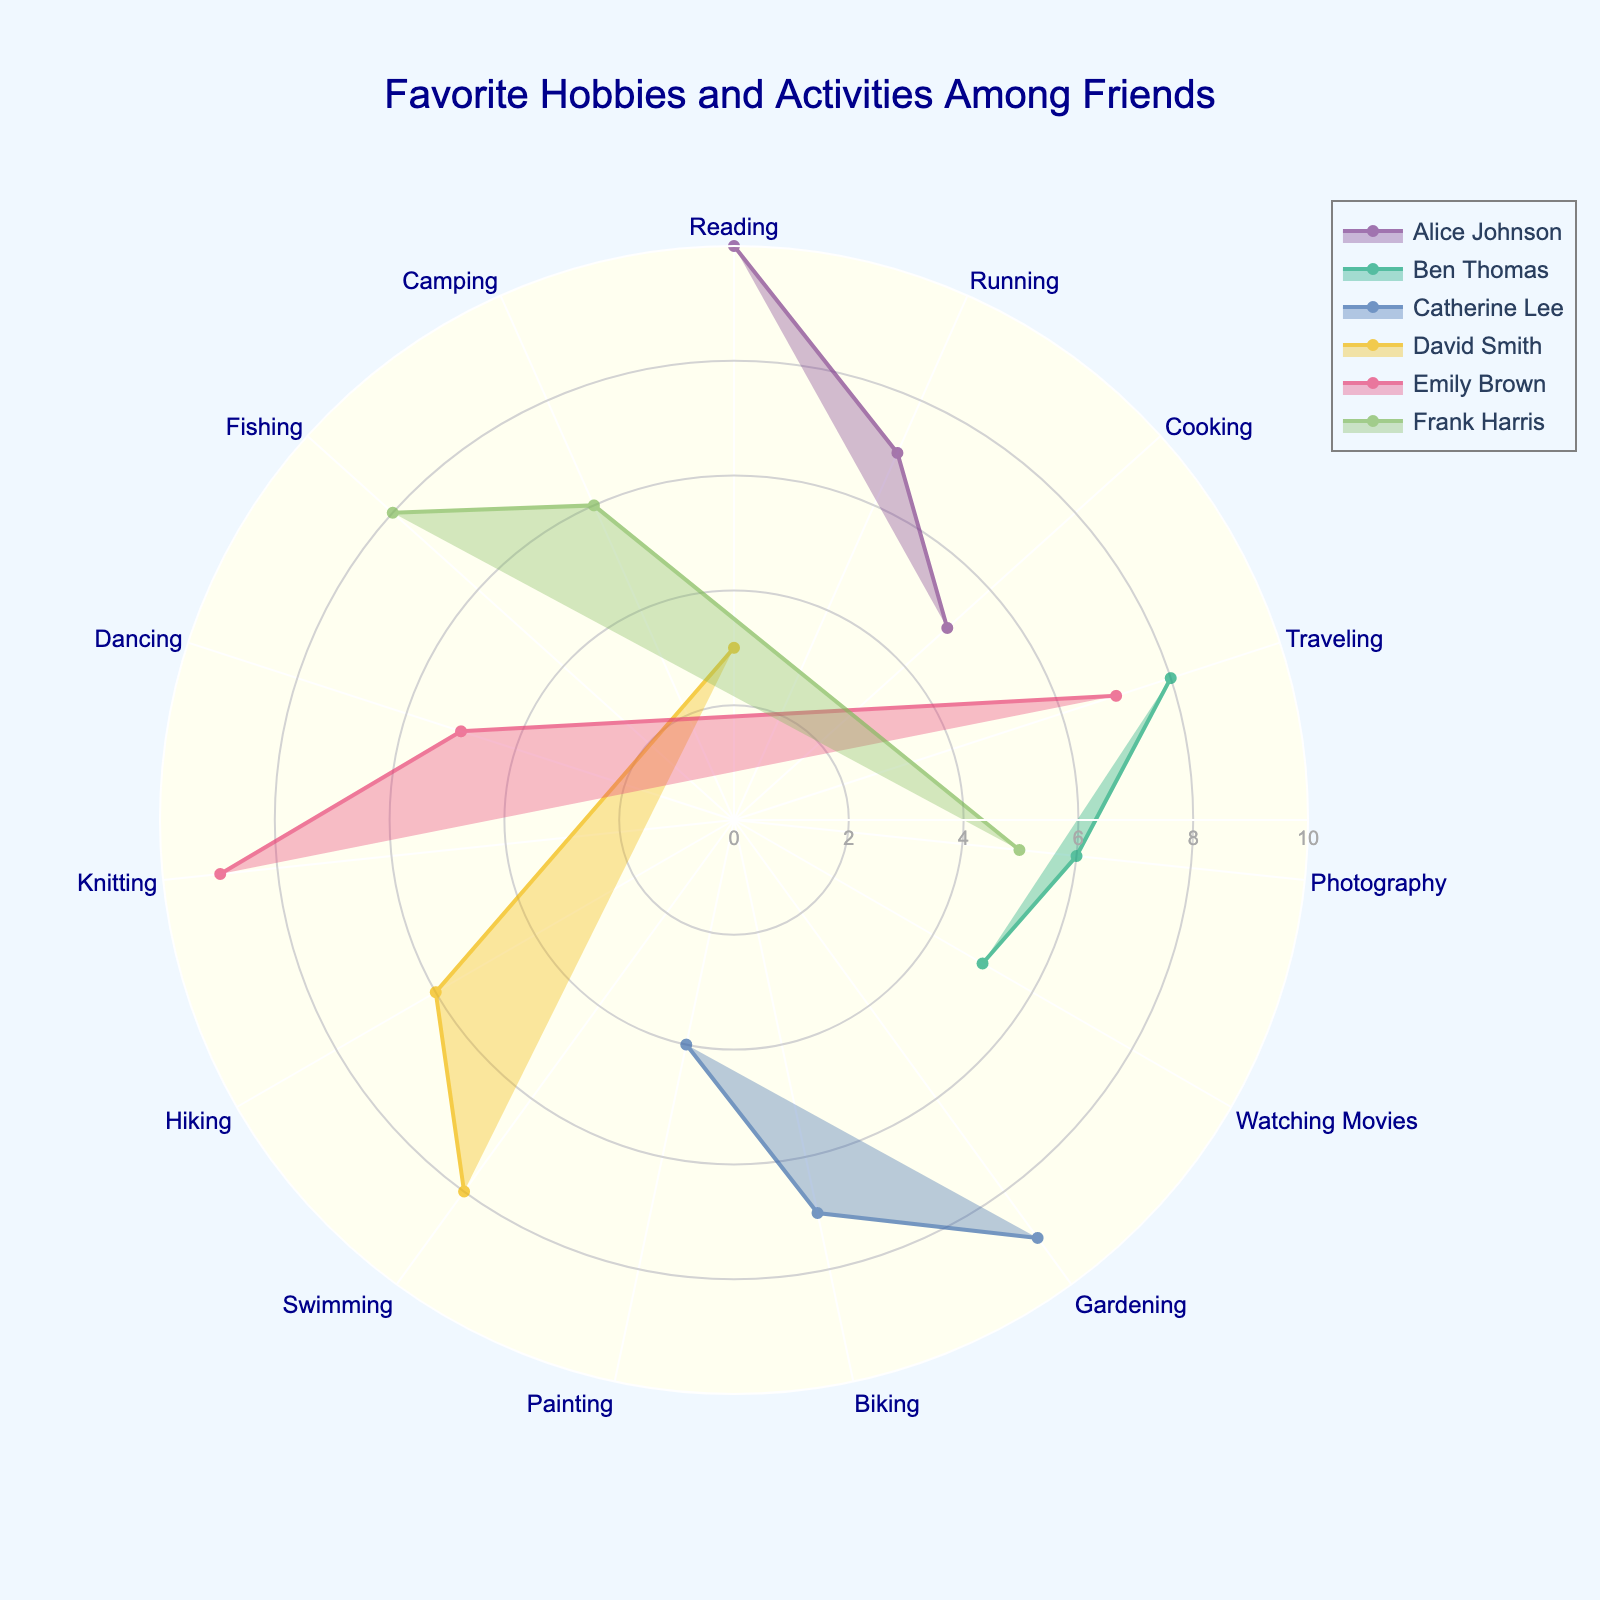How many friends' activities are depicted in the chart? The chart contains separate plots for each friend. Each plot is distinguishable by color and labeled with the friend’s name in the legend. Counting these labels will give us the number of friends.
Answer: 6 Which friend has the highest engagement in Gardening? By observing the points for Gardening on the chart, we can see that Catherine Lee engages in Gardening the most. The radial distance for each friend's Gardening activity will indicate their engagement level.
Answer: Catherine Lee What's the combined frequency of Reading by Alice Johnson and David Smith? Find the radial distance for "Reading" for both Alice Johnson and David Smith and sum these values. According to the chart, Alice has a 10 for Reading and David has a 3. So, 10 + 3 = 13.
Answer: 13 Which friend participates most frequently in Traveling? Look for the plot points related to Traveling, and compare the radial distances for each friend. The friend with the farthest radial distance at Traveling is Ben Thomas.
Answer: Ben Thomas Who has a more diverse range of activities, Catherine Lee or Frank Harris? Diversity can be assessed by counting the unique activities for each friend in the chart. Both Catherine Lee and Frank Harris have 3 activities each. However, we then compare the engagement levels in these activities. Frank Harris has uniformly higher engagement across his activities.
Answer: Tie Is there a friend who engages in both Photography and Traveling? Look at the chart and check for friends who have points plotted for both Photography and Traveling. Emily Brown and Ben Thomas are the two with these activities.
Answer: Ben Thomas, Emily Brown What's the average frequency of Emily Brown's activities? Sum the radial distances for all Emily Brown's activities (Knitting, Dancing, and Traveling) and divide them by the number of activities. This is (9 + 5 + 7)/3 = 7.
Answer: 7 